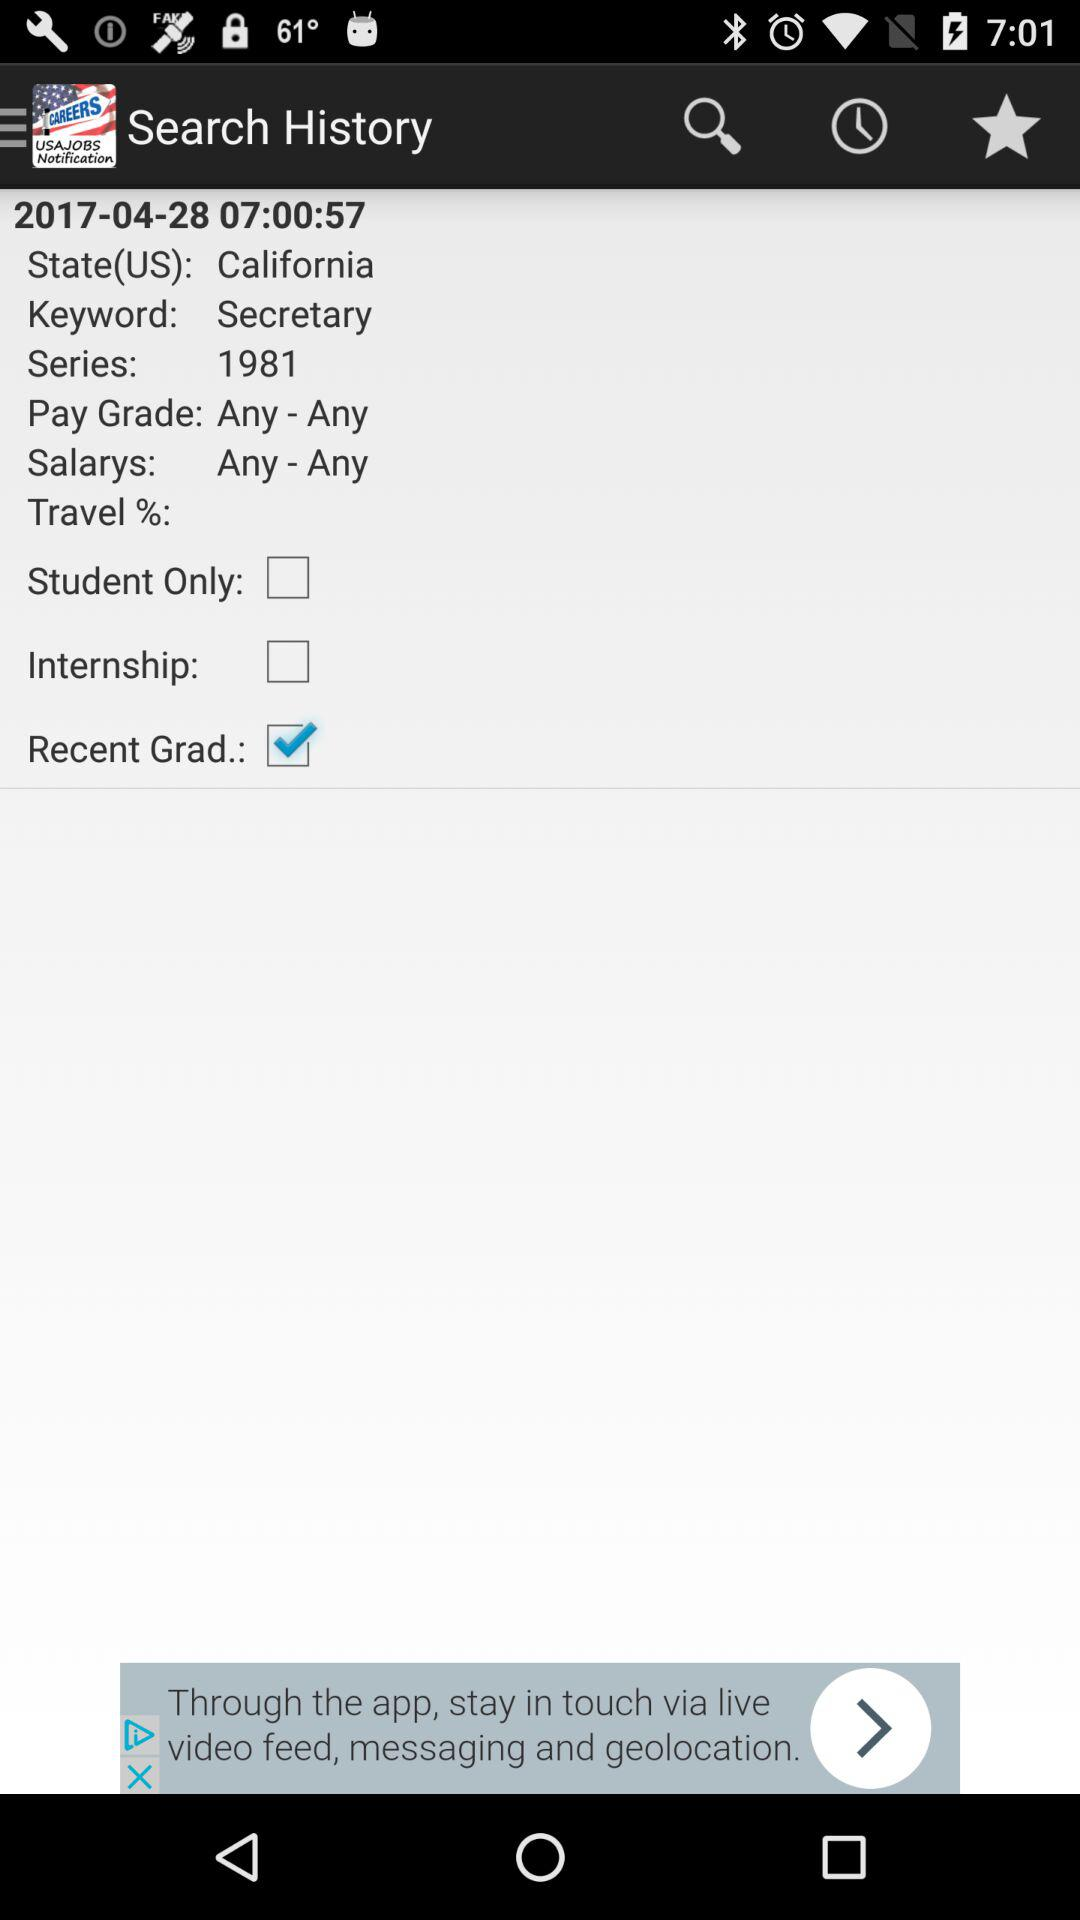What's the series year? The series year is 1981. 